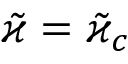<formula> <loc_0><loc_0><loc_500><loc_500>\tilde { \varkappa } = \tilde { \varkappa } _ { c }</formula> 